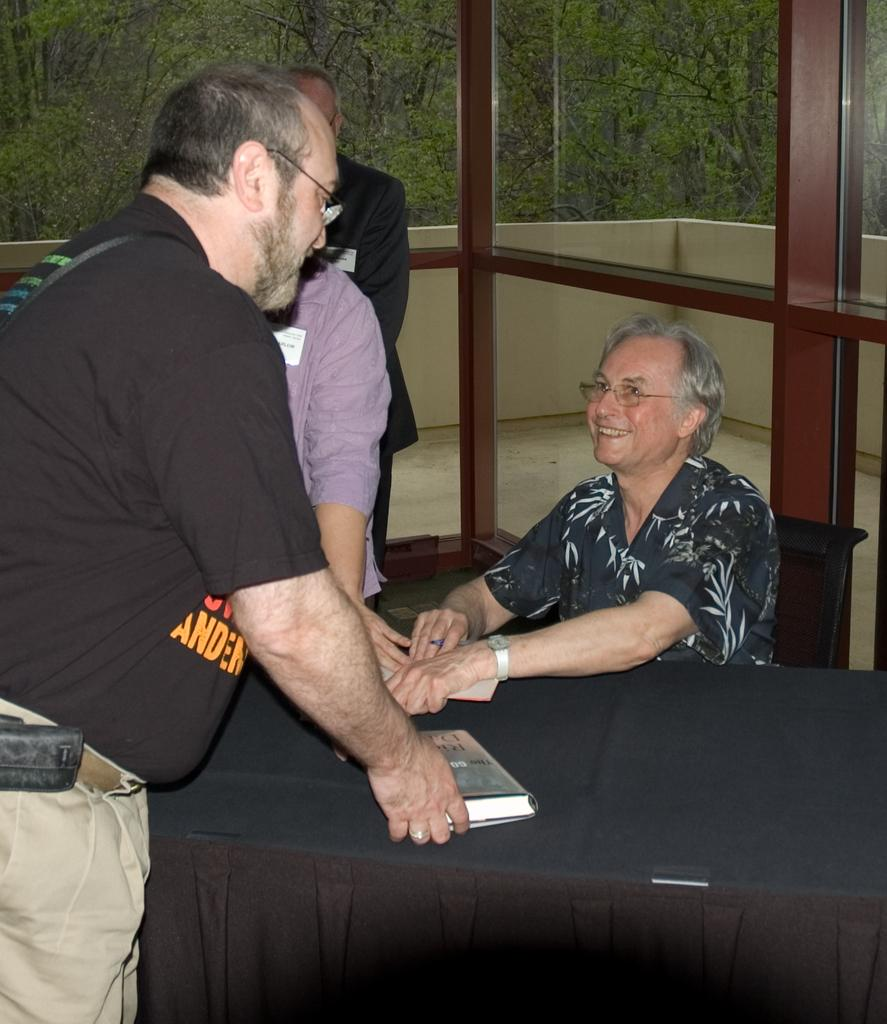How many people are in the image? There are two people in the image. What are the positions of the people in the image? One person is sitting on a table, and the other person is sitting on a chair. What can be seen in the background of the image? There are trees visible in the image. What type of mint can be seen growing near the trees in the image? There is no mint visible in the image, as it only features two people and trees in the background. 